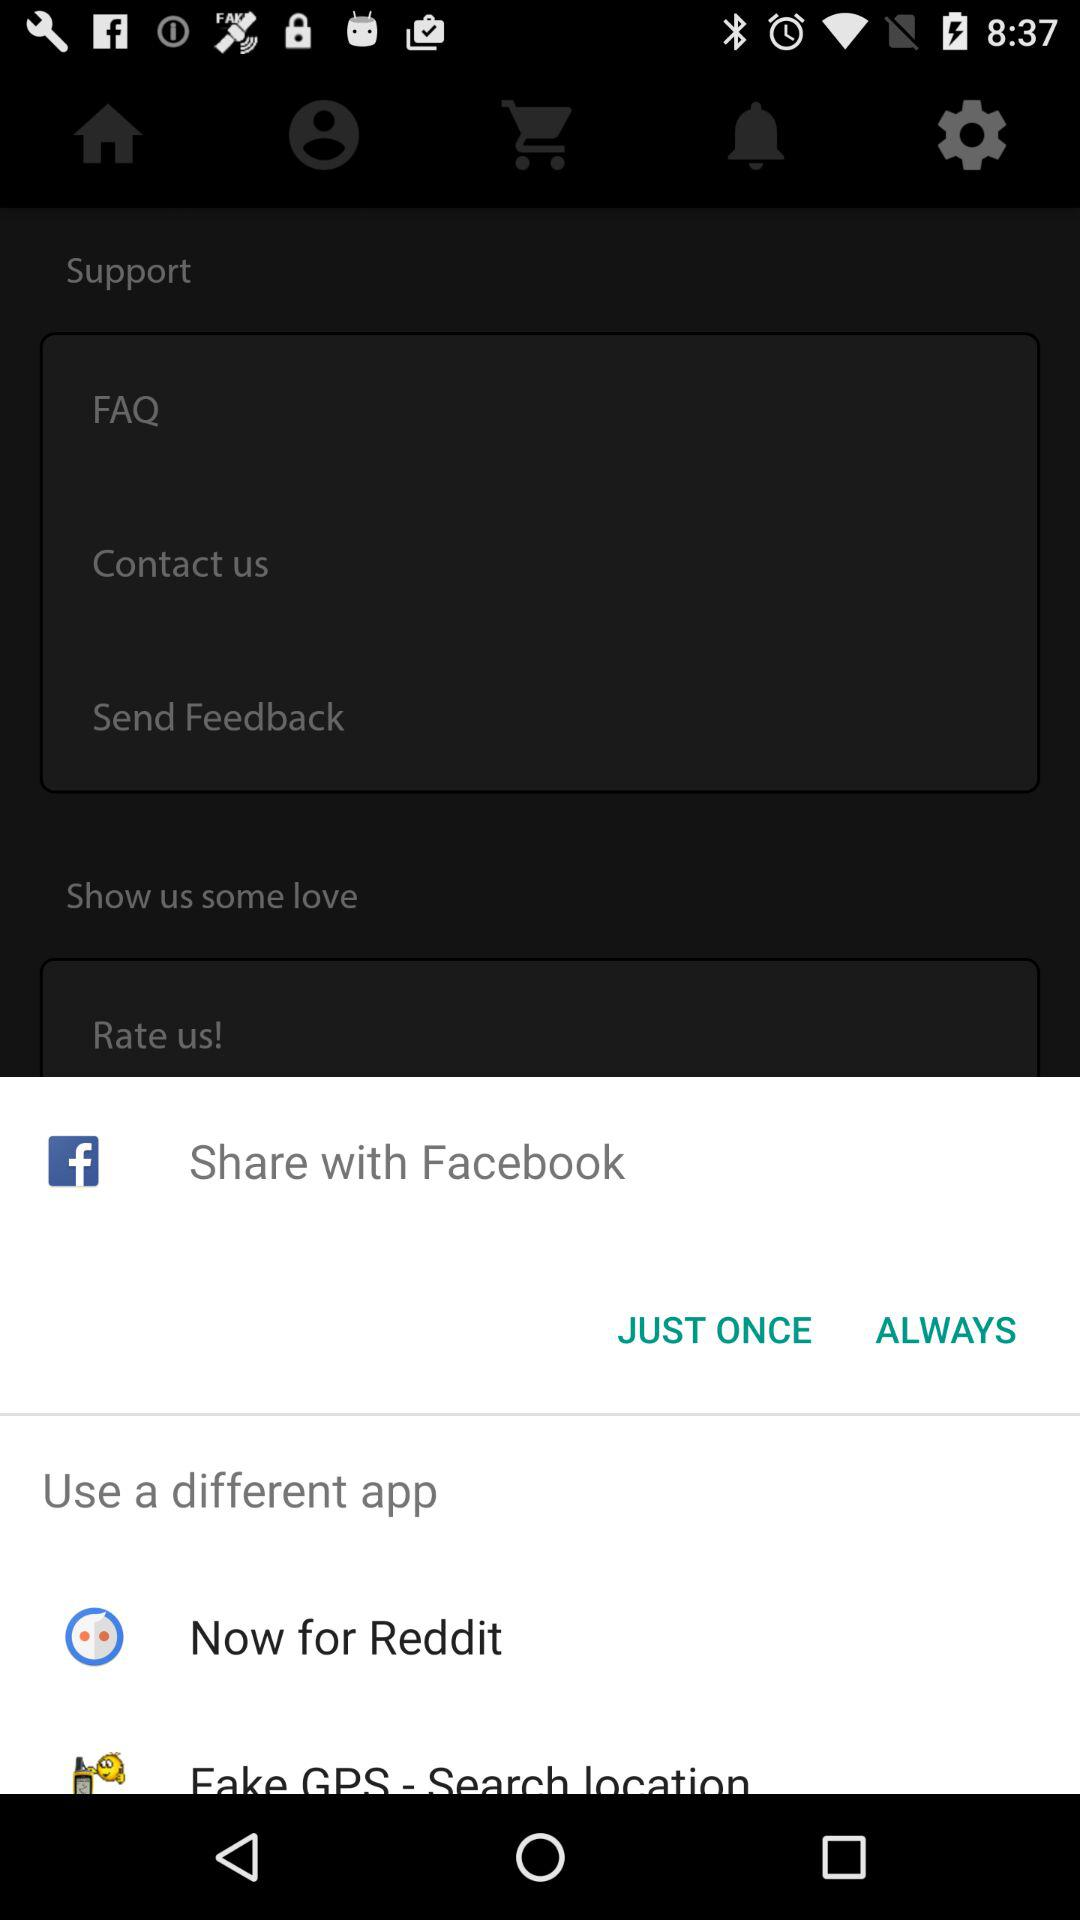Through what app can I share? You can share with "Share with Facebook", "Now for Reddit", and "Fake GPS - Search location". 